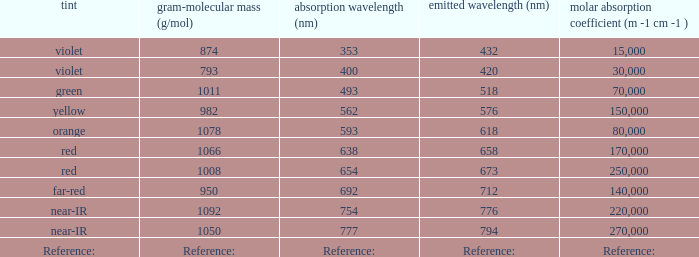What is the Absorbtion (in nanometers) of the color Orange? 593.0. 